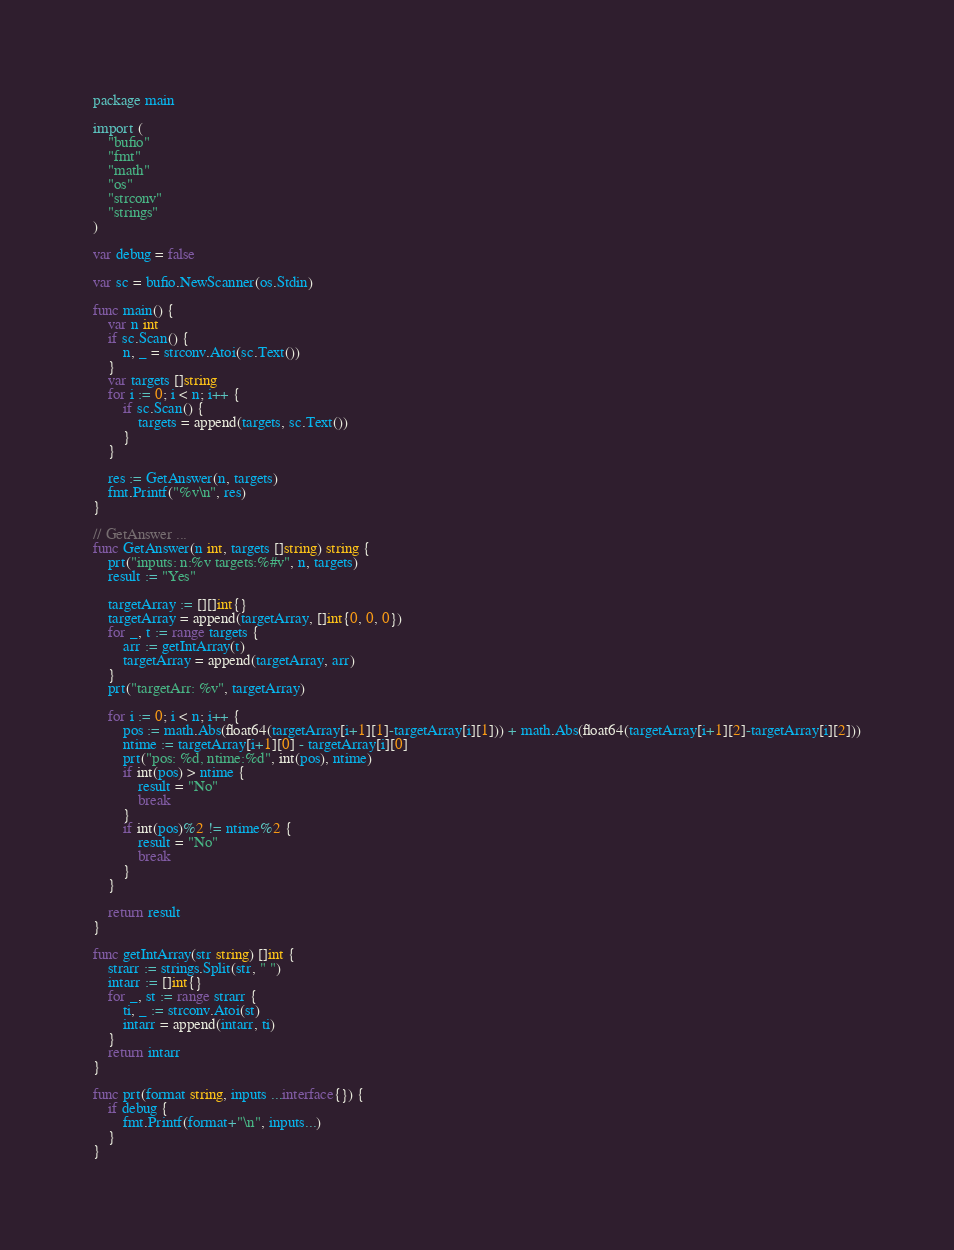Convert code to text. <code><loc_0><loc_0><loc_500><loc_500><_Go_>package main

import (
	"bufio"
	"fmt"
	"math"
	"os"
	"strconv"
	"strings"
)

var debug = false

var sc = bufio.NewScanner(os.Stdin)

func main() {
	var n int
	if sc.Scan() {
		n, _ = strconv.Atoi(sc.Text())
	}
	var targets []string
	for i := 0; i < n; i++ {
		if sc.Scan() {
			targets = append(targets, sc.Text())
		}
	}

	res := GetAnswer(n, targets)
	fmt.Printf("%v\n", res)
}

// GetAnswer ...
func GetAnswer(n int, targets []string) string {
	prt("inputs: n:%v targets:%#v", n, targets)
	result := "Yes"

	targetArray := [][]int{}
	targetArray = append(targetArray, []int{0, 0, 0})
	for _, t := range targets {
		arr := getIntArray(t)
		targetArray = append(targetArray, arr)
	}
	prt("targetArr: %v", targetArray)

	for i := 0; i < n; i++ {
		pos := math.Abs(float64(targetArray[i+1][1]-targetArray[i][1])) + math.Abs(float64(targetArray[i+1][2]-targetArray[i][2]))
		ntime := targetArray[i+1][0] - targetArray[i][0]
		prt("pos: %d, ntime:%d", int(pos), ntime)
		if int(pos) > ntime {
			result = "No"
			break
		}
		if int(pos)%2 != ntime%2 {
			result = "No"
			break
		}
	}

	return result
}

func getIntArray(str string) []int {
	strarr := strings.Split(str, " ")
	intarr := []int{}
	for _, st := range strarr {
		ti, _ := strconv.Atoi(st)
		intarr = append(intarr, ti)
	}
	return intarr
}

func prt(format string, inputs ...interface{}) {
	if debug {
		fmt.Printf(format+"\n", inputs...)
	}
}</code> 